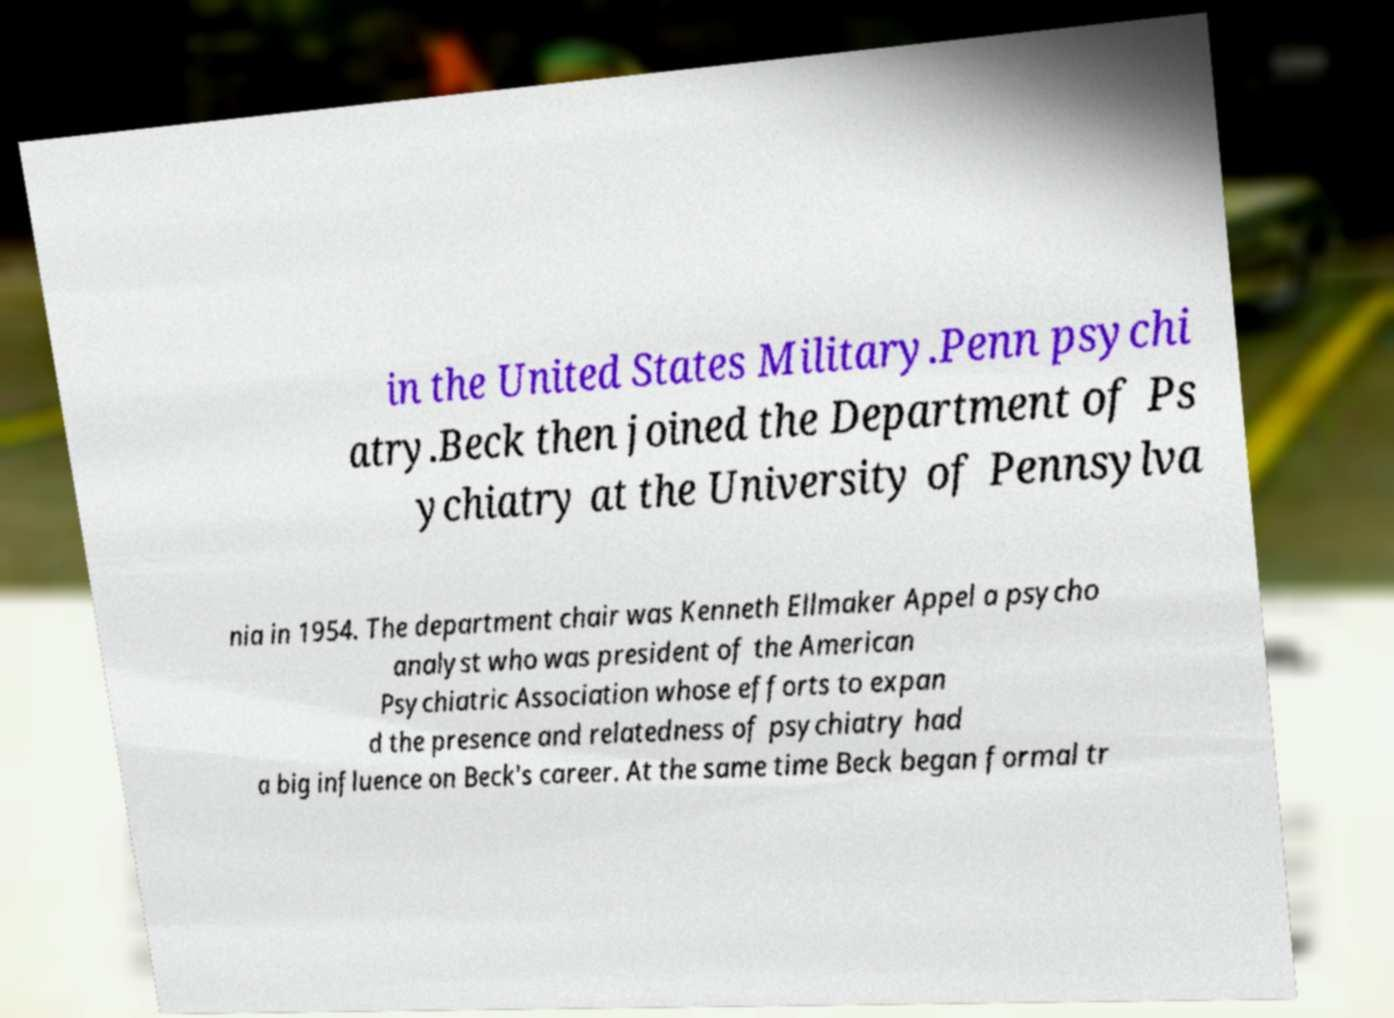Can you accurately transcribe the text from the provided image for me? in the United States Military.Penn psychi atry.Beck then joined the Department of Ps ychiatry at the University of Pennsylva nia in 1954. The department chair was Kenneth Ellmaker Appel a psycho analyst who was president of the American Psychiatric Association whose efforts to expan d the presence and relatedness of psychiatry had a big influence on Beck's career. At the same time Beck began formal tr 